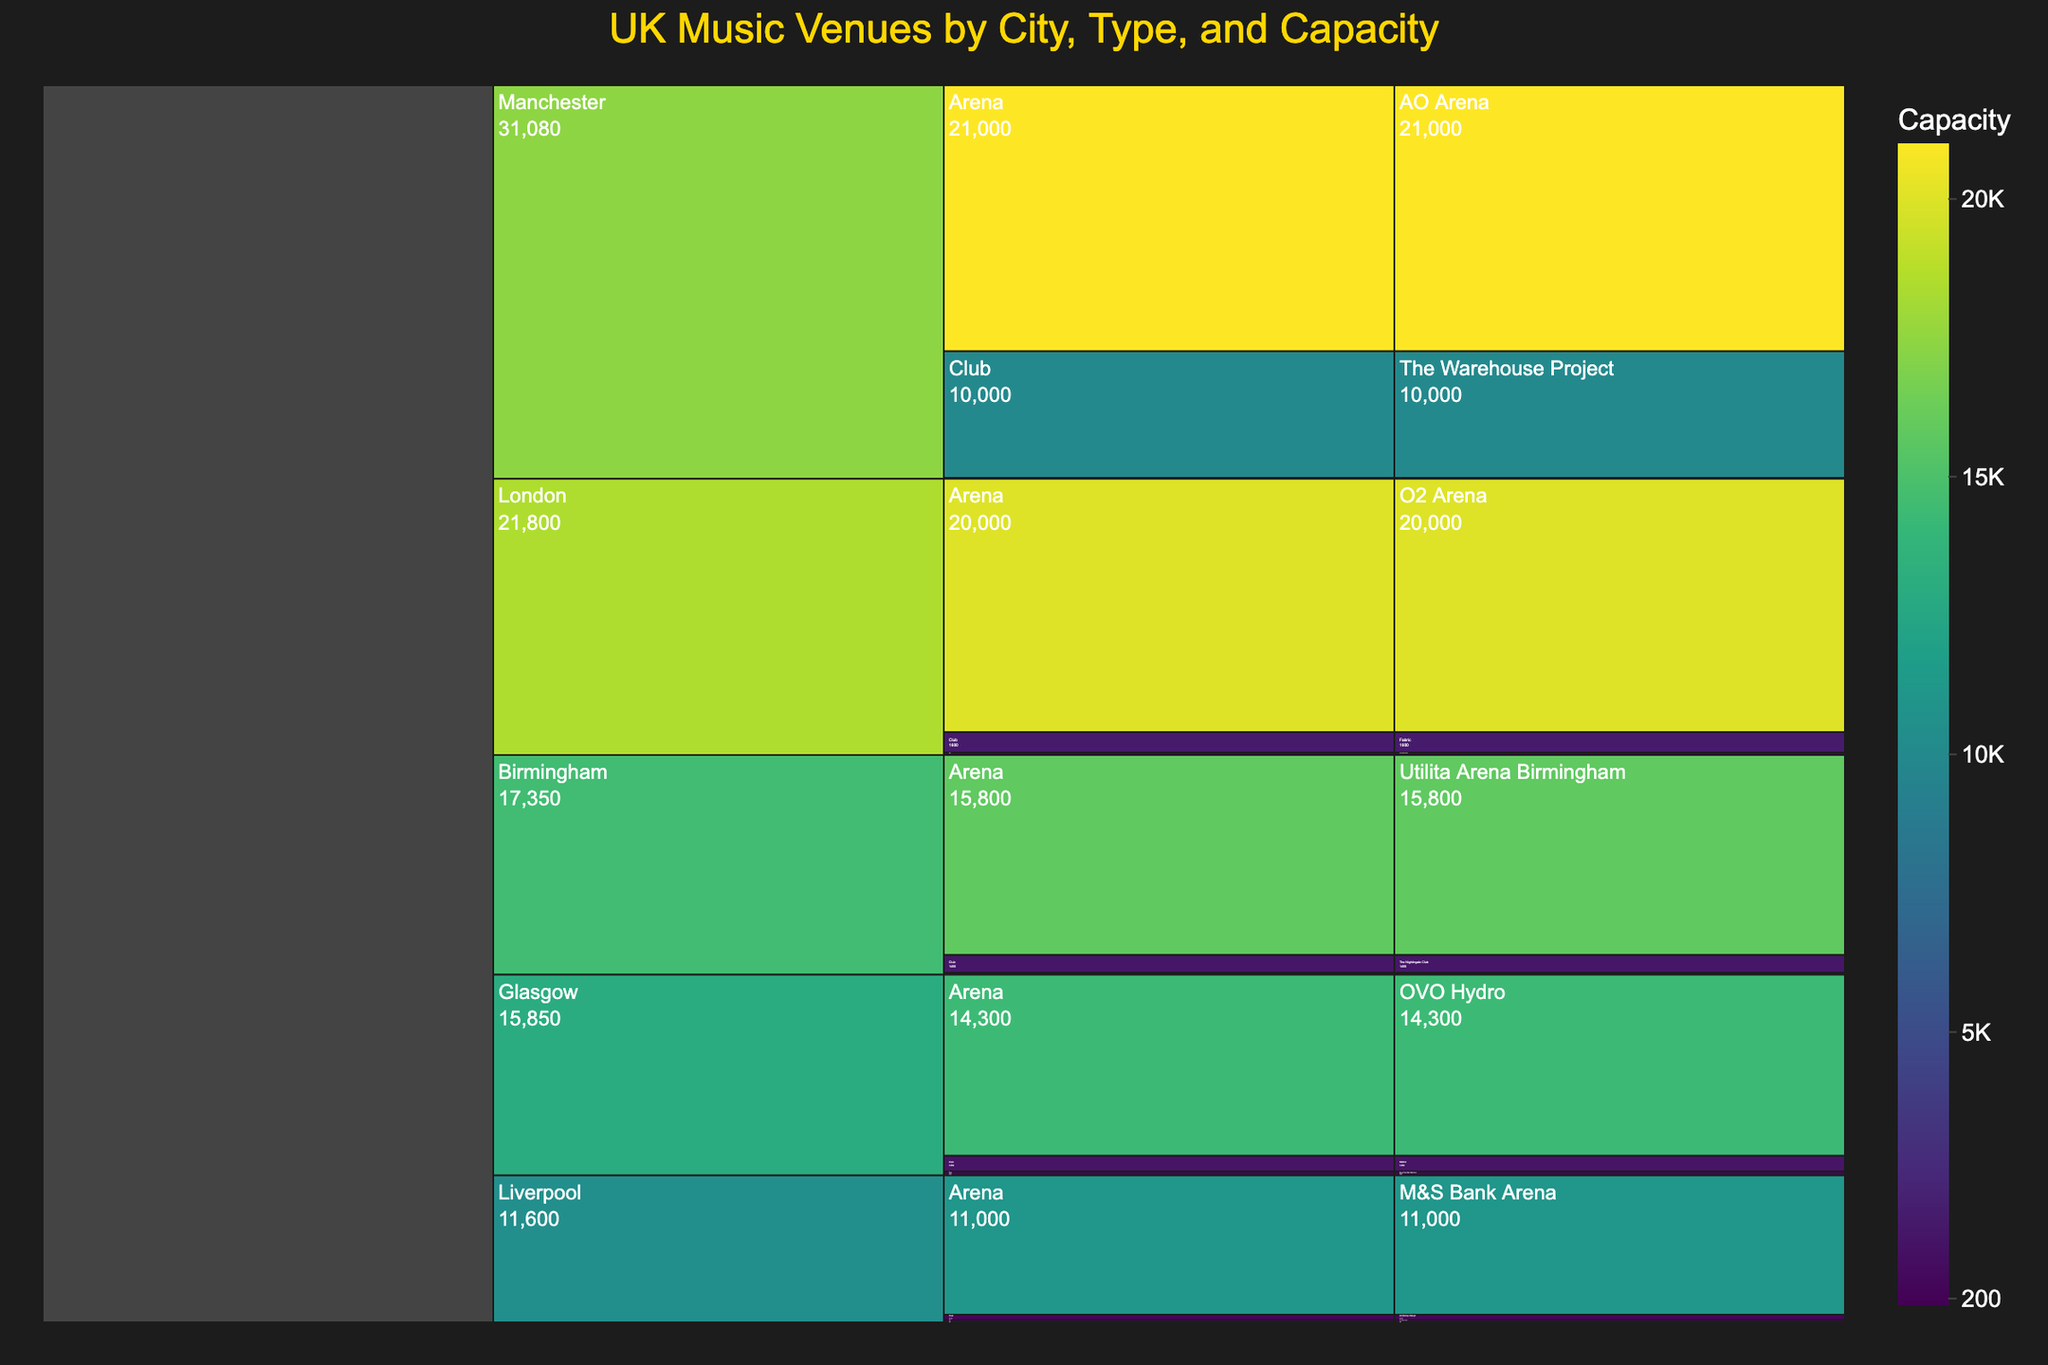What's the title of the figure? The title is displayed at the top of the chart, highlighting the main subject being addressed in the visual representation.
Answer: UK Music Venues by City, Type, and Capacity Which city has the venue with the highest capacity? The icicle chart displays venues organized by city and their respective capacities with the colors transitioning according to size; the largest unit will be the darkest (or lightest, depending on the color scale).
Answer: Manchester What's the total capacity of the venues in Liverpool? To find the total capacity, add the capacities of all the venues in Liverpool. These are M&S Bank Arena (11000), 24 Kitchen Street (400), and The Cavern Club (200).
Answer: 11600 How does the number of Arena type venues compare between Manchester and Birmingham? Find the count of Arena type venues under each city node. Manchester and Birmingham each have one Arena type venue.
Answer: Equal Which venue type generally has the lowest capacities across all cities? Observing the icicle chart, each city's venues are divided into Arena, Club, and Pub classifications; the Pub-type venues exhibit the smallest capacity values among all the categories.
Answer: Pub What is the difference in capacity between London's largest and smallest venues? In London, the O2 Arena has a capacity of 20000, and The Dublin Castle has a capacity of 200. Subtracting these values gives the difference.
Answer: 19800 What's the average capacity of club venues in Glasgow? For Glasgow, the only club venue is SWG3 with a capacity of 1250. As there is only one data point, the average is the capacity itself.
Answer: 1250 How many cities have at least one venue with a capacity above 20000? By checking the values on the icicle chart, only Manchester has a venue, AO Arena, with a capacity above 20000.
Answer: 1 Is there a greater variety of venue types in London or Liverpool? Each city shows venue subdivisions into Arena, Club, and Pub types, therefore both cities have an equal variety of venue types.
Answer: Equal Which city has the smallest-capacity venue among all, and what's its capacity? The smallest capacity can be discerned by the smallest segment in the icicle chart; in this case, it's The Castle Hotel in Manchester with a capacity of 80.
Answer: Manchester, 80 